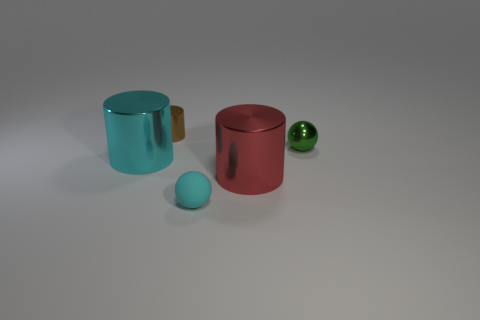How many other objects are the same color as the small rubber thing?
Your answer should be compact. 1. There is a cylinder behind the tiny sphere that is to the right of the ball in front of the red thing; what is its color?
Give a very brief answer. Brown. How many metal cylinders are both in front of the tiny metallic ball and on the left side of the tiny cyan matte object?
Provide a succinct answer. 1. What number of cylinders are small green objects or big cyan objects?
Keep it short and to the point. 1. Is there a large yellow matte thing?
Give a very brief answer. No. What number of other objects are the same material as the tiny brown cylinder?
Provide a succinct answer. 3. There is a cyan thing that is the same size as the green metal object; what is its material?
Provide a succinct answer. Rubber. There is a big shiny object to the right of the rubber thing; is it the same shape as the cyan metal object?
Your answer should be very brief. Yes. How many objects are large metallic objects on the left side of the brown metal object or tiny cyan metal objects?
Make the answer very short. 1. The green metallic object that is the same size as the rubber sphere is what shape?
Offer a very short reply. Sphere. 